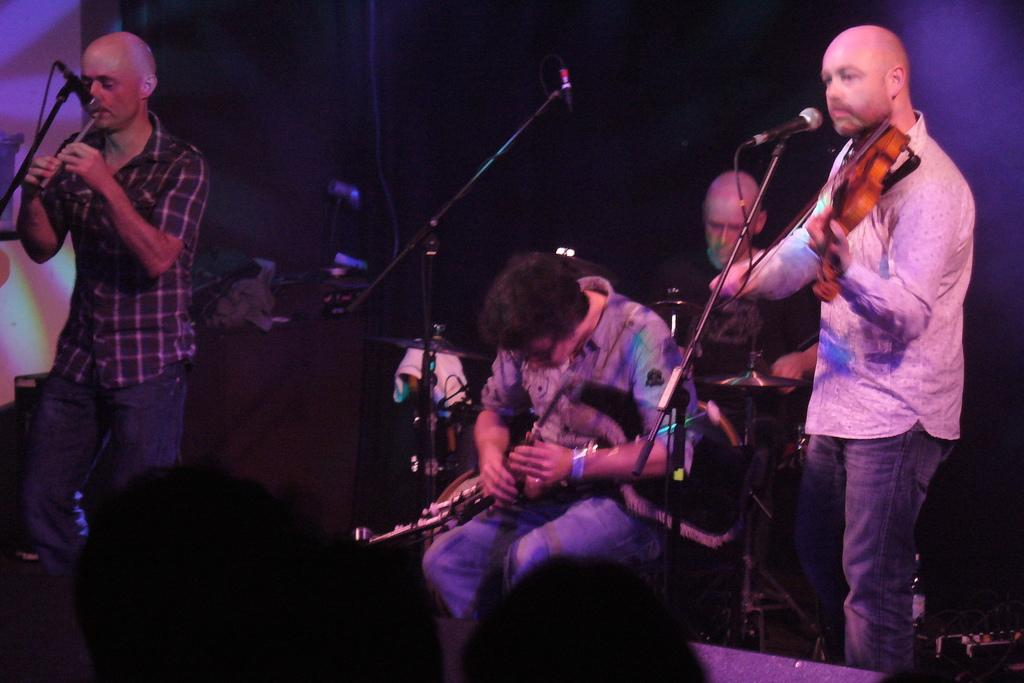How many people are in the image? There are four people in the image. What are the people doing in the image? The people are playing musical instruments. What objects are in front of the people? There are microphones in front of the people. What can be observed about the lighting in the image? The background of the image is dark. What type of club can be seen in the hands of the people playing musical instruments? There is no club present in the image; the people are holding musical instruments and microphones. Can you tell me how many times the grandmother has visited the location in the image? There is no mention of a grandmother or any visits in the image; it features four people playing musical instruments and using microphones. 